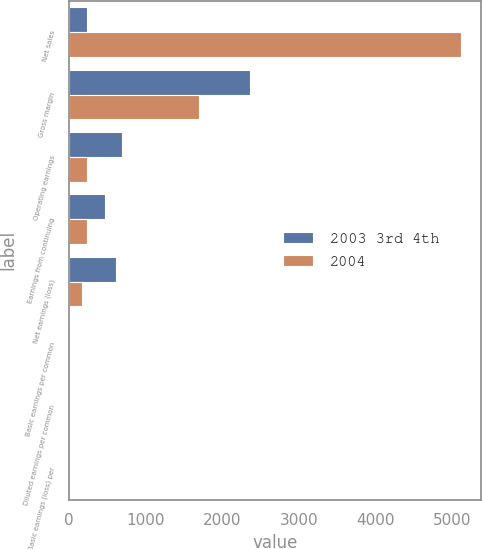Convert chart. <chart><loc_0><loc_0><loc_500><loc_500><stacked_bar_chart><ecel><fcel>Net sales<fcel>Gross margin<fcel>Operating earnings<fcel>Earnings from continuing<fcel>Net earnings (loss)<fcel>Basic earnings per common<fcel>Diluted earnings per common<fcel>Basic earnings (loss) per<nl><fcel>2003 3rd 4th<fcel>236<fcel>2366<fcel>685<fcel>466<fcel>609<fcel>0.2<fcel>0.19<fcel>0.26<nl><fcel>2004<fcel>5119<fcel>1698<fcel>237<fcel>236<fcel>169<fcel>0.1<fcel>0.1<fcel>0.07<nl></chart> 